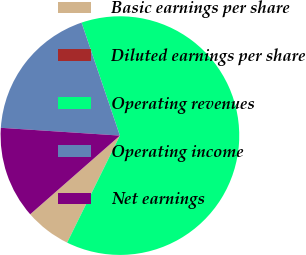Convert chart to OTSL. <chart><loc_0><loc_0><loc_500><loc_500><pie_chart><fcel>Basic earnings per share<fcel>Diluted earnings per share<fcel>Operating revenues<fcel>Operating income<fcel>Net earnings<nl><fcel>6.25%<fcel>0.0%<fcel>62.5%<fcel>18.75%<fcel>12.5%<nl></chart> 